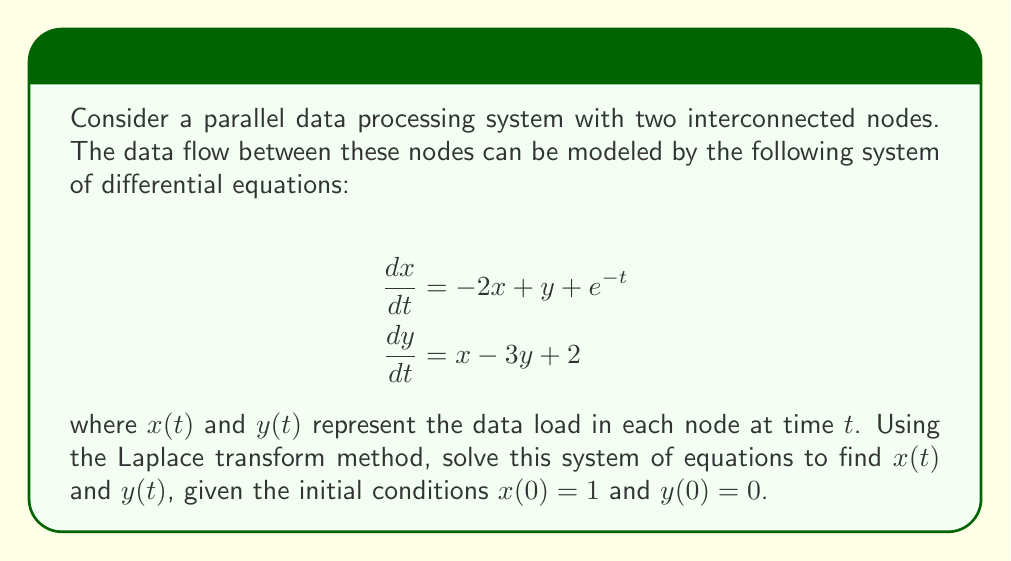Show me your answer to this math problem. Let's solve this step-by-step using the Laplace transform method:

1) First, let's take the Laplace transform of both equations:

   For the first equation:
   $$\mathcal{L}\{\frac{dx}{dt}\} = \mathcal{L}\{-2x + y + e^{-t}\}$$
   $$sX(s) - x(0) = -2X(s) + Y(s) + \frac{1}{s+1}$$

   For the second equation:
   $$\mathcal{L}\{\frac{dy}{dt}\} = \mathcal{L}\{x - 3y + 2\}$$
   $$sY(s) - y(0) = X(s) - 3Y(s) + \frac{2}{s}$$

2) Substitute the initial conditions $x(0) = 1$ and $y(0) = 0$:

   $$sX(s) - 1 = -2X(s) + Y(s) + \frac{1}{s+1}$$
   $$sY(s) = X(s) - 3Y(s) + \frac{2}{s}$$

3) Rearrange the equations:

   $$(s+2)X(s) - Y(s) = 1 + \frac{1}{s+1}$$
   $$X(s) - (s+3)Y(s) = -\frac{2}{s}$$

4) Solve this system of equations for X(s) and Y(s) using substitution or matrix methods:

   $$X(s) = \frac{s^3 + 5s^2 + 4s + 2}{s^4 + 5s^3 + 7s^2 + 3s}$$
   $$Y(s) = \frac{s^2 + 3s + 2}{s^4 + 5s^3 + 7s^2 + 3s}$$

5) To find x(t) and y(t), we need to take the inverse Laplace transform of X(s) and Y(s). This involves partial fraction decomposition:

   $$X(s) = \frac{1}{s} + \frac{1}{s+1} - \frac{1}{s+2} - \frac{1}{s+3}$$
   $$Y(s) = \frac{1}{s} - \frac{1}{s+1} - \frac{1}{s+2} + \frac{1}{s+3}$$

6) Taking the inverse Laplace transform:

   $$x(t) = 1 + e^{-t} - e^{-2t} - e^{-3t}$$
   $$y(t) = 1 - e^{-t} - e^{-2t} + e^{-3t}$$

These are the solutions for x(t) and y(t).
Answer: $$x(t) = 1 + e^{-t} - e^{-2t} - e^{-3t}$$
$$y(t) = 1 - e^{-t} - e^{-2t} + e^{-3t}$$ 